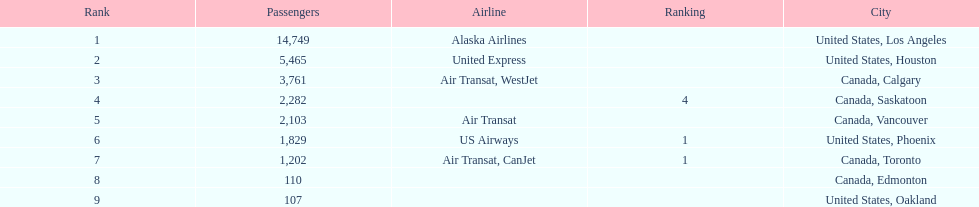The least number of passengers came from which city United States, Oakland. 